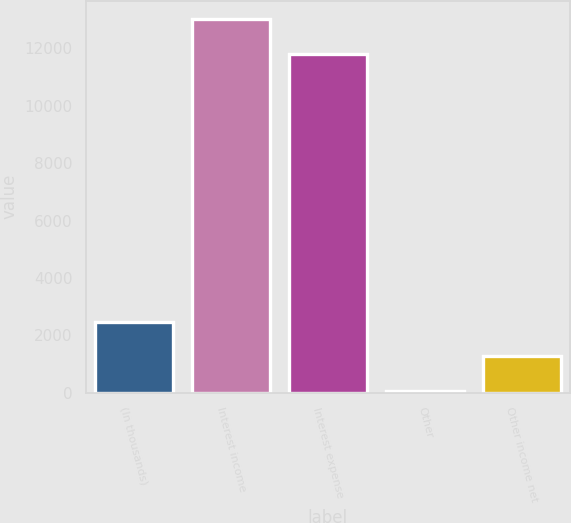<chart> <loc_0><loc_0><loc_500><loc_500><bar_chart><fcel>(In thousands)<fcel>Interest income<fcel>Interest expense<fcel>Other<fcel>Other income net<nl><fcel>2457.2<fcel>13011.6<fcel>11820<fcel>74<fcel>1265.6<nl></chart> 